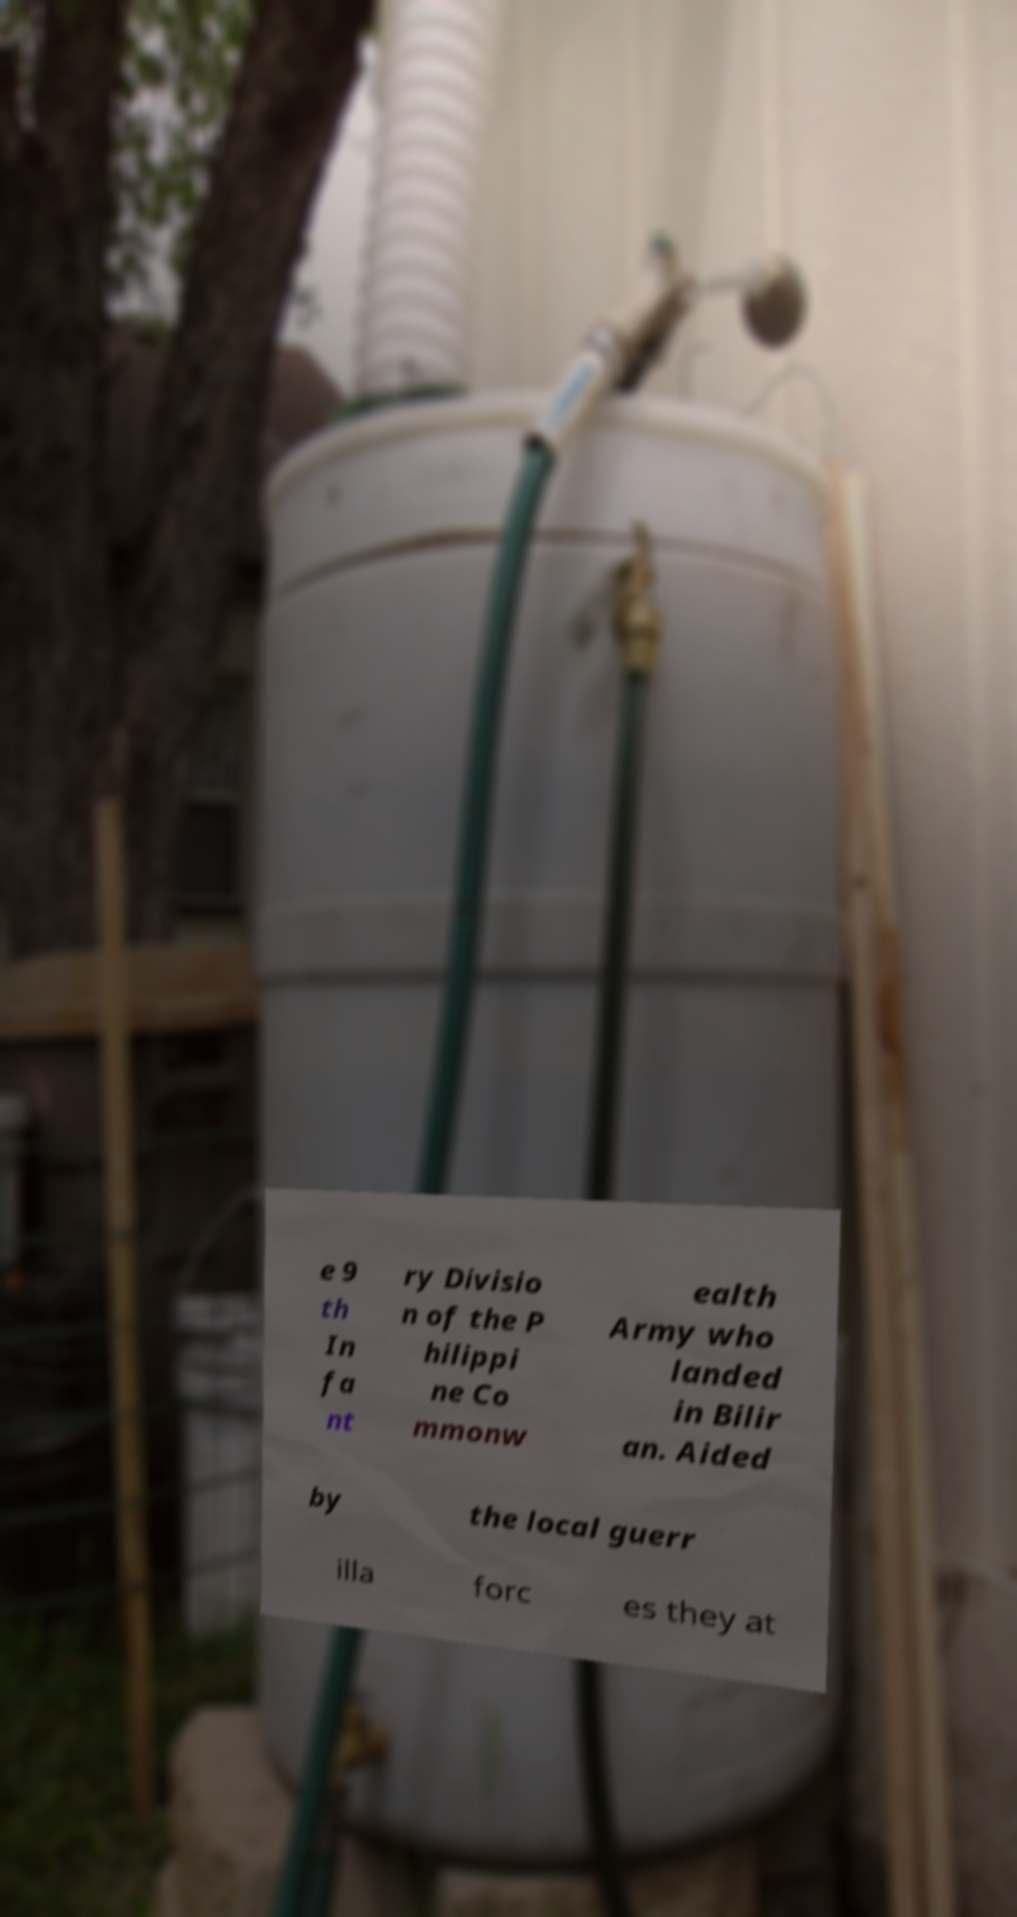Could you assist in decoding the text presented in this image and type it out clearly? e 9 th In fa nt ry Divisio n of the P hilippi ne Co mmonw ealth Army who landed in Bilir an. Aided by the local guerr illa forc es they at 